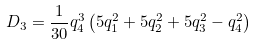<formula> <loc_0><loc_0><loc_500><loc_500>D _ { 3 } = \frac { 1 } { 3 0 } q _ { 4 } ^ { 3 } \left ( 5 q _ { 1 } ^ { 2 } + 5 q _ { 2 } ^ { 2 } + 5 q _ { 3 } ^ { 2 } - q _ { 4 } ^ { 2 } \right )</formula> 